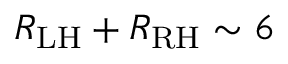Convert formula to latex. <formula><loc_0><loc_0><loc_500><loc_500>R _ { L H } + R _ { R H } \sim 6 \</formula> 